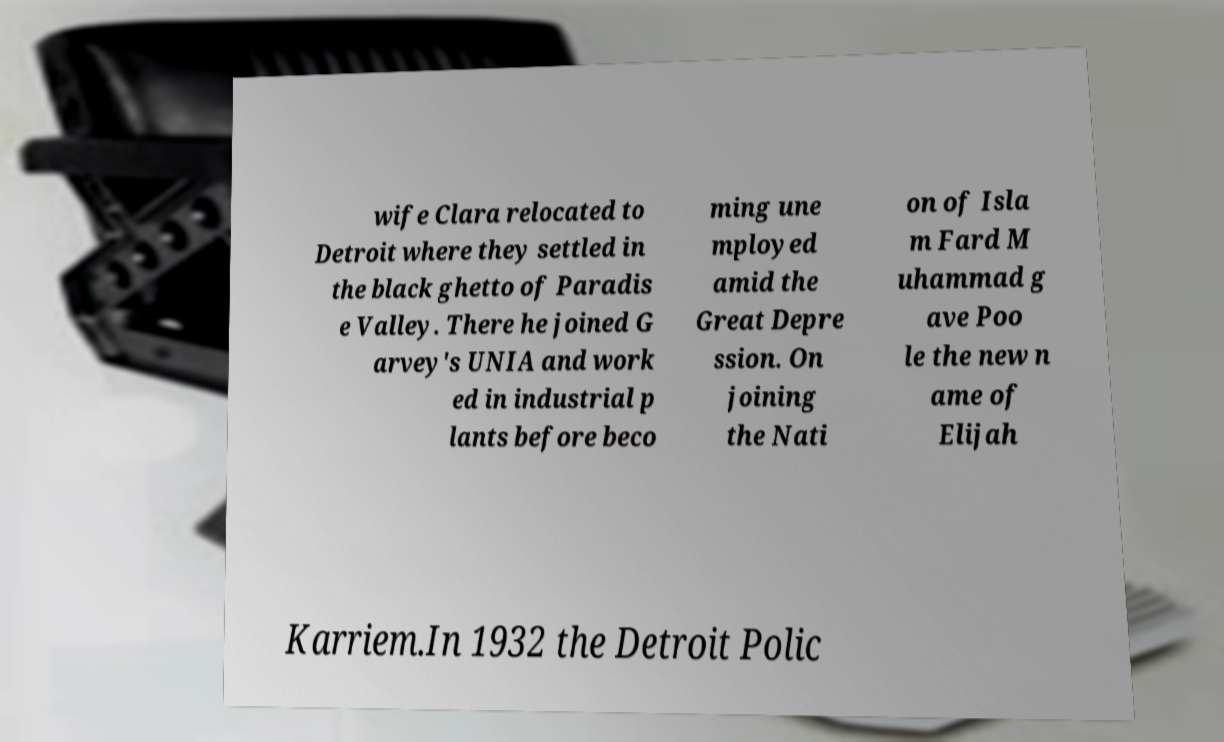Could you extract and type out the text from this image? wife Clara relocated to Detroit where they settled in the black ghetto of Paradis e Valley. There he joined G arvey's UNIA and work ed in industrial p lants before beco ming une mployed amid the Great Depre ssion. On joining the Nati on of Isla m Fard M uhammad g ave Poo le the new n ame of Elijah Karriem.In 1932 the Detroit Polic 